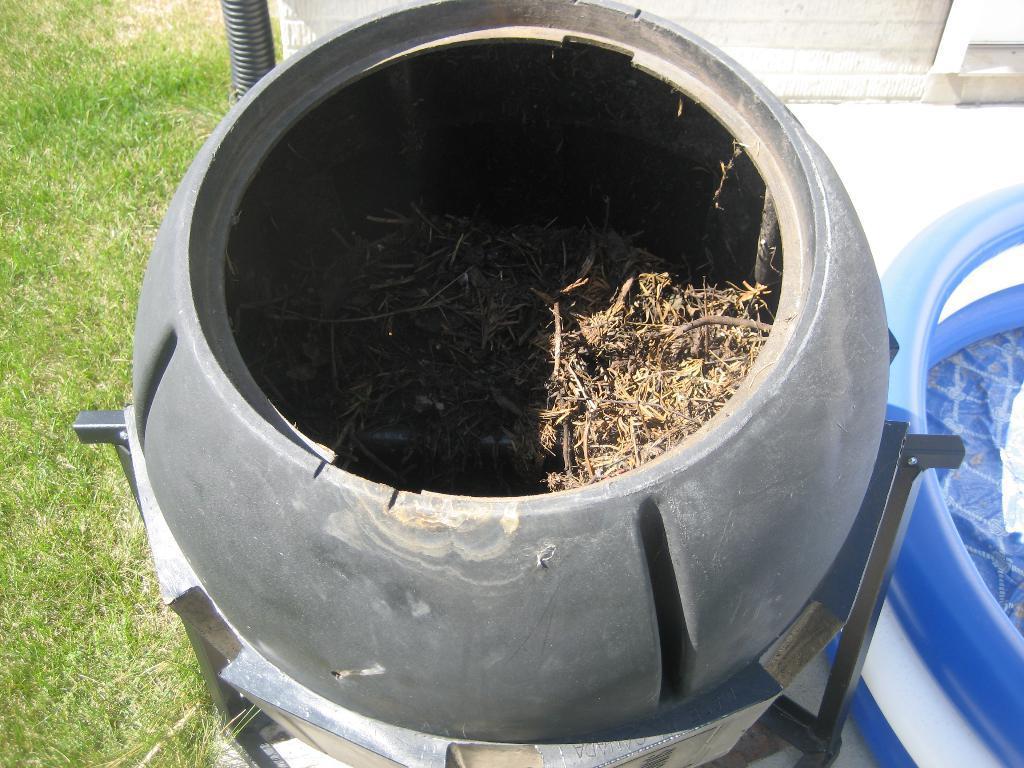Could you give a brief overview of what you see in this image? In this image I can see the black color object on the stand and I can see the grass in it. I can see the tube in blue and white color. 